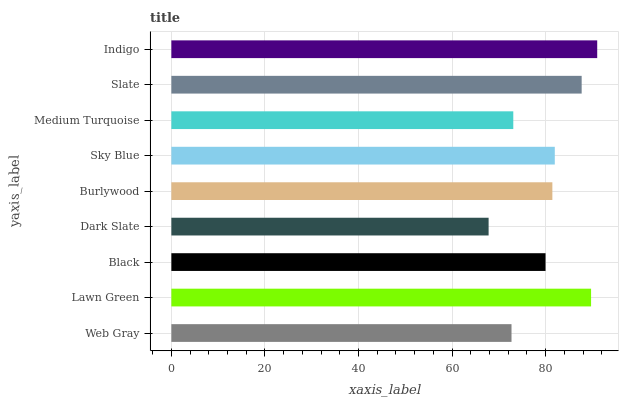Is Dark Slate the minimum?
Answer yes or no. Yes. Is Indigo the maximum?
Answer yes or no. Yes. Is Lawn Green the minimum?
Answer yes or no. No. Is Lawn Green the maximum?
Answer yes or no. No. Is Lawn Green greater than Web Gray?
Answer yes or no. Yes. Is Web Gray less than Lawn Green?
Answer yes or no. Yes. Is Web Gray greater than Lawn Green?
Answer yes or no. No. Is Lawn Green less than Web Gray?
Answer yes or no. No. Is Burlywood the high median?
Answer yes or no. Yes. Is Burlywood the low median?
Answer yes or no. Yes. Is Slate the high median?
Answer yes or no. No. Is Dark Slate the low median?
Answer yes or no. No. 